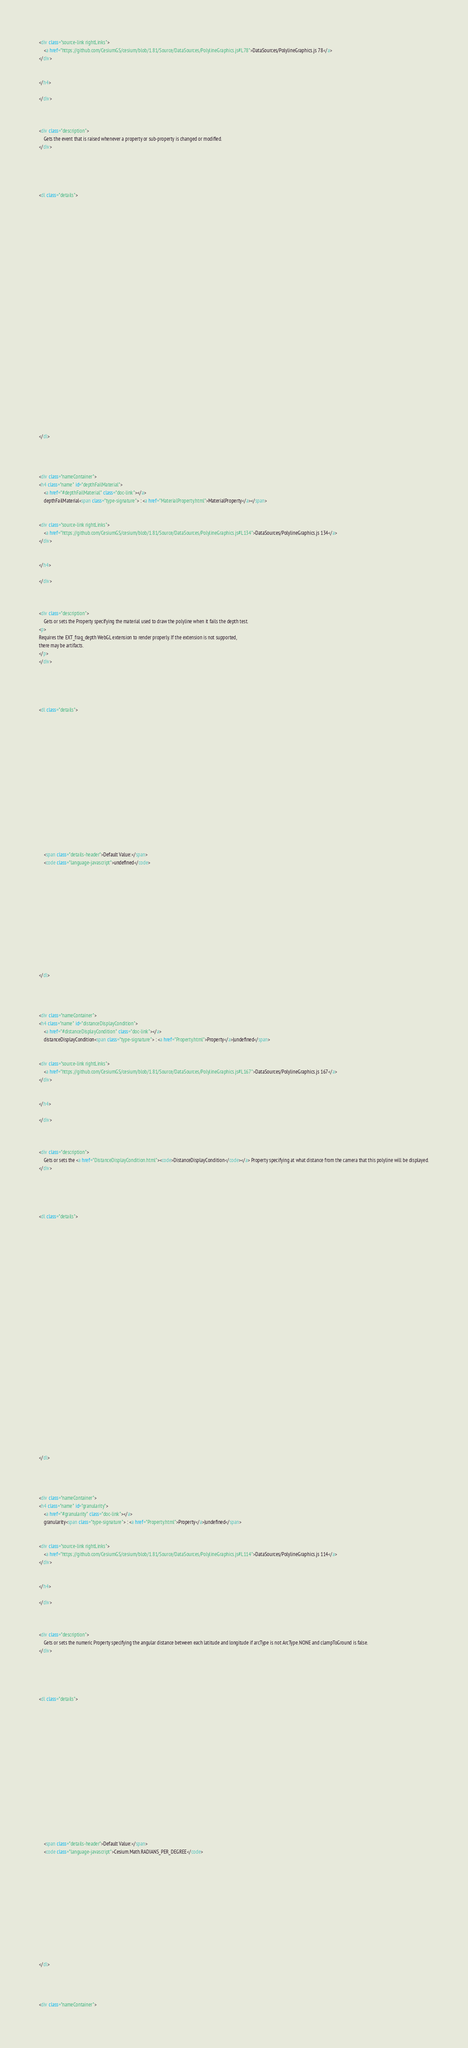<code> <loc_0><loc_0><loc_500><loc_500><_HTML_><div class="source-link rightLinks">
    <a href="https://github.com/CesiumGS/cesium/blob/1.81/Source/DataSources/PolylineGraphics.js#L78">DataSources/PolylineGraphics.js 78</a>
</div>


</h4>

</div>



<div class="description">
    Gets the event that is raised whenever a property or sub-property is changed or modified.
</div>





<dl class="details">


    

    

    

    

    

    

    

    

    

    

    

    

    

    
</dl>


        
            
<div class="nameContainer">
<h4 class="name" id="depthFailMaterial">
    <a href="#depthFailMaterial" class="doc-link"></a>
    depthFailMaterial<span class="type-signature"> : <a href="MaterialProperty.html">MaterialProperty</a></span>
    

<div class="source-link rightLinks">
    <a href="https://github.com/CesiumGS/cesium/blob/1.81/Source/DataSources/PolylineGraphics.js#L134">DataSources/PolylineGraphics.js 134</a>
</div>


</h4>

</div>



<div class="description">
    Gets or sets the Property specifying the material used to draw the polyline when it fails the depth test.
<p>
Requires the EXT_frag_depth WebGL extension to render properly. If the extension is not supported,
there may be artifacts.
</p>
</div>





<dl class="details">


    

    

    

    

    

    

    

    
    <span class="details-header">Default Value:</span>
    <code class="language-javascript">undefined</code>
    

    

    

    

    

    

    
</dl>


        
            
<div class="nameContainer">
<h4 class="name" id="distanceDisplayCondition">
    <a href="#distanceDisplayCondition" class="doc-link"></a>
    distanceDisplayCondition<span class="type-signature"> : <a href="Property.html">Property</a>|undefined</span>
    

<div class="source-link rightLinks">
    <a href="https://github.com/CesiumGS/cesium/blob/1.81/Source/DataSources/PolylineGraphics.js#L167">DataSources/PolylineGraphics.js 167</a>
</div>


</h4>

</div>



<div class="description">
    Gets or sets the <a href="DistanceDisplayCondition.html"><code>DistanceDisplayCondition</code></a> Property specifying at what distance from the camera that this polyline will be displayed.
</div>





<dl class="details">


    

    

    

    

    

    

    

    

    

    

    

    

    

    
</dl>


        
            
<div class="nameContainer">
<h4 class="name" id="granularity">
    <a href="#granularity" class="doc-link"></a>
    granularity<span class="type-signature"> : <a href="Property.html">Property</a>|undefined</span>
    

<div class="source-link rightLinks">
    <a href="https://github.com/CesiumGS/cesium/blob/1.81/Source/DataSources/PolylineGraphics.js#L114">DataSources/PolylineGraphics.js 114</a>
</div>


</h4>

</div>



<div class="description">
    Gets or sets the numeric Property specifying the angular distance between each latitude and longitude if arcType is not ArcType.NONE and clampToGround is false.
</div>





<dl class="details">


    

    

    

    

    

    

    

    
    <span class="details-header">Default Value:</span>
    <code class="language-javascript">Cesium.Math.RADIANS_PER_DEGREE</code>
    

    

    

    

    

    

    
</dl>


        
            
<div class="nameContainer"></code> 